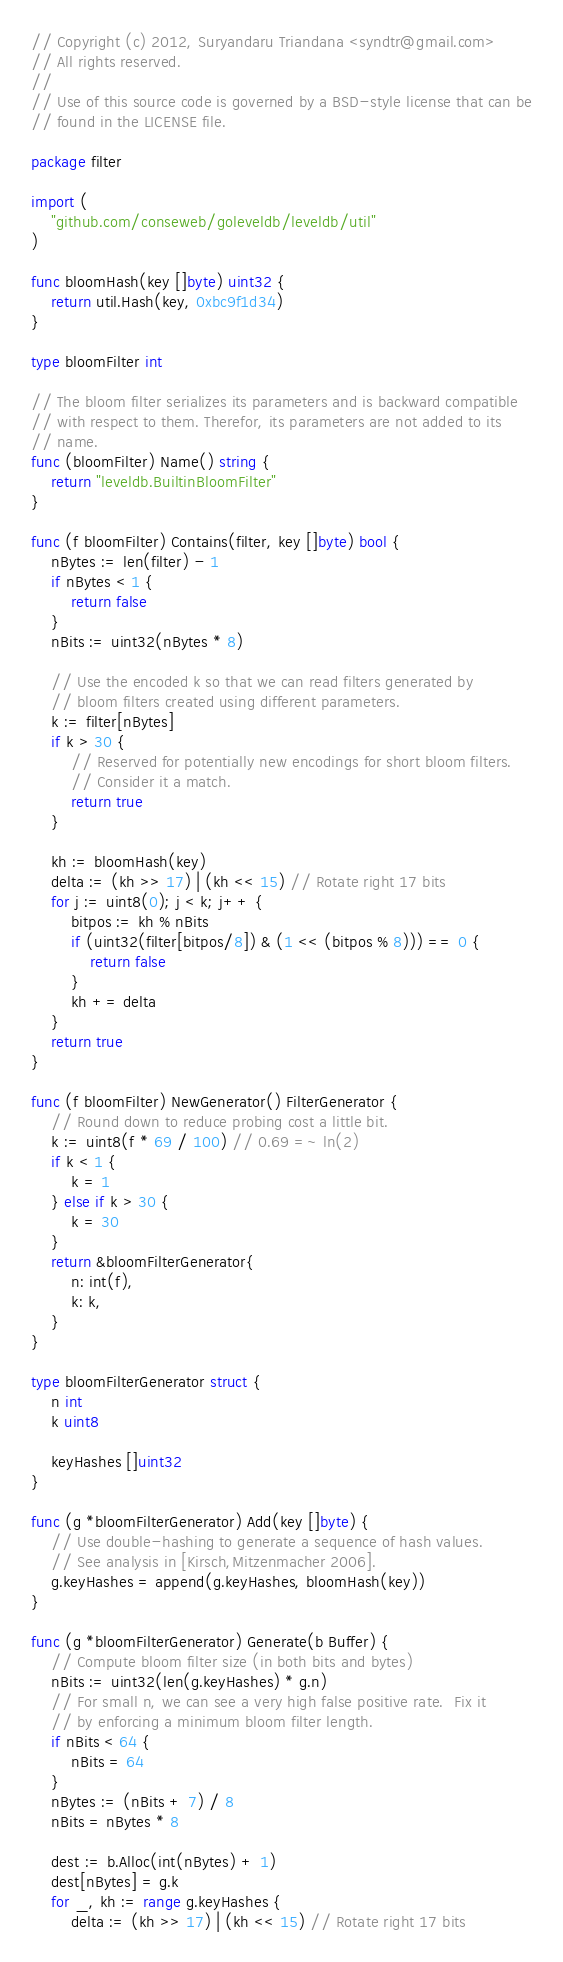Convert code to text. <code><loc_0><loc_0><loc_500><loc_500><_Go_>// Copyright (c) 2012, Suryandaru Triandana <syndtr@gmail.com>
// All rights reserved.
//
// Use of this source code is governed by a BSD-style license that can be
// found in the LICENSE file.

package filter

import (
	"github.com/conseweb/goleveldb/leveldb/util"
)

func bloomHash(key []byte) uint32 {
	return util.Hash(key, 0xbc9f1d34)
}

type bloomFilter int

// The bloom filter serializes its parameters and is backward compatible
// with respect to them. Therefor, its parameters are not added to its
// name.
func (bloomFilter) Name() string {
	return "leveldb.BuiltinBloomFilter"
}

func (f bloomFilter) Contains(filter, key []byte) bool {
	nBytes := len(filter) - 1
	if nBytes < 1 {
		return false
	}
	nBits := uint32(nBytes * 8)

	// Use the encoded k so that we can read filters generated by
	// bloom filters created using different parameters.
	k := filter[nBytes]
	if k > 30 {
		// Reserved for potentially new encodings for short bloom filters.
		// Consider it a match.
		return true
	}

	kh := bloomHash(key)
	delta := (kh >> 17) | (kh << 15) // Rotate right 17 bits
	for j := uint8(0); j < k; j++ {
		bitpos := kh % nBits
		if (uint32(filter[bitpos/8]) & (1 << (bitpos % 8))) == 0 {
			return false
		}
		kh += delta
	}
	return true
}

func (f bloomFilter) NewGenerator() FilterGenerator {
	// Round down to reduce probing cost a little bit.
	k := uint8(f * 69 / 100) // 0.69 =~ ln(2)
	if k < 1 {
		k = 1
	} else if k > 30 {
		k = 30
	}
	return &bloomFilterGenerator{
		n: int(f),
		k: k,
	}
}

type bloomFilterGenerator struct {
	n int
	k uint8

	keyHashes []uint32
}

func (g *bloomFilterGenerator) Add(key []byte) {
	// Use double-hashing to generate a sequence of hash values.
	// See analysis in [Kirsch,Mitzenmacher 2006].
	g.keyHashes = append(g.keyHashes, bloomHash(key))
}

func (g *bloomFilterGenerator) Generate(b Buffer) {
	// Compute bloom filter size (in both bits and bytes)
	nBits := uint32(len(g.keyHashes) * g.n)
	// For small n, we can see a very high false positive rate.  Fix it
	// by enforcing a minimum bloom filter length.
	if nBits < 64 {
		nBits = 64
	}
	nBytes := (nBits + 7) / 8
	nBits = nBytes * 8

	dest := b.Alloc(int(nBytes) + 1)
	dest[nBytes] = g.k
	for _, kh := range g.keyHashes {
		delta := (kh >> 17) | (kh << 15) // Rotate right 17 bits</code> 